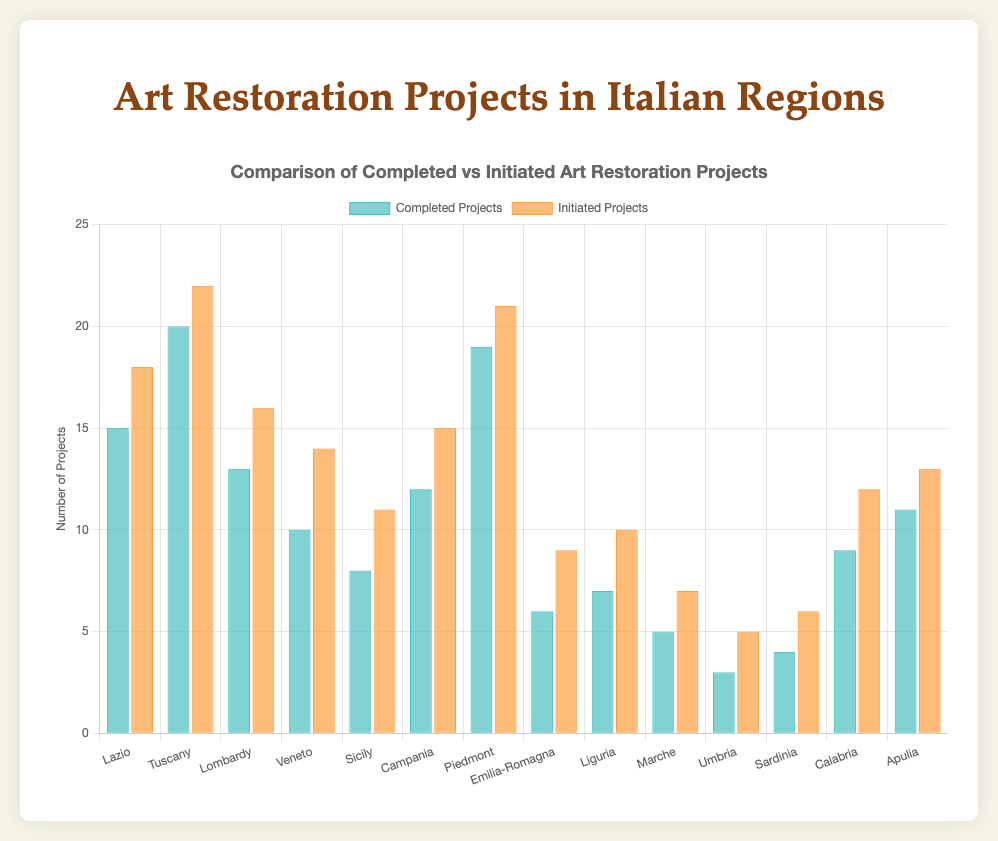What's the total number of completed projects in Tuscany and Piedmont? Add the number of completed projects in Tuscany (20) and Piedmont (19). 20 + 19 = 39
Answer: 39 Which region has the highest number of initiated projects? The region with the highest number of initiated projects is visible as the one with the tallest orange bar. Tuscany has the tallest orange bar with 22 initiated projects.
Answer: Tuscany Is the number of initiated projects in Lazio greater than or equal to the number of completed projects in Lombardy? Compare the number of initiated projects in Lazio (18) with the number of completed projects in Lombardy (13). 18 is greater than 13.
Answer: Yes By how much do completed projects in Campania outnumber initiated projects in Umbria? Subtract the number of initiated projects in Umbria (5) from the number of completed projects in Campania (12). 12 - 5 = 7
Answer: 7 Which regions have more completed than initiated projects? Compare the height of blue and orange bars for each region. No region has a taller blue bar than an orange bar, meaning no region has more completed than initiated projects.
Answer: None What is the difference between initiated and completed projects in Veneto? Subtract the number of completed projects in Veneto (10) from the number of initiated projects in Veneto (14). 14 - 10 = 4
Answer: 4 What is the average number of completed projects across all regions? Sum the number of completed projects across all regions and then divide by the number of regions (14). (15 + 20 + 13 + 10 + 8 + 12 + 19 + 6 + 7 + 5 + 3 + 4 + 9 + 11) / 14 ≈ 10.71
Answer: 10.71 Which regions have exactly 5 projects initiated? The regions with an orange bar corresponding to exactly 5 height units is Umbria.
Answer: Umbria 